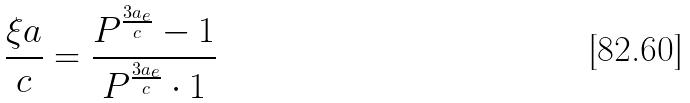Convert formula to latex. <formula><loc_0><loc_0><loc_500><loc_500>\frac { \xi a } { c } = \frac { P ^ { \frac { 3 a _ { e } } { c } } - 1 } { P ^ { \frac { 3 a _ { e } } { c } } \cdot 1 }</formula> 